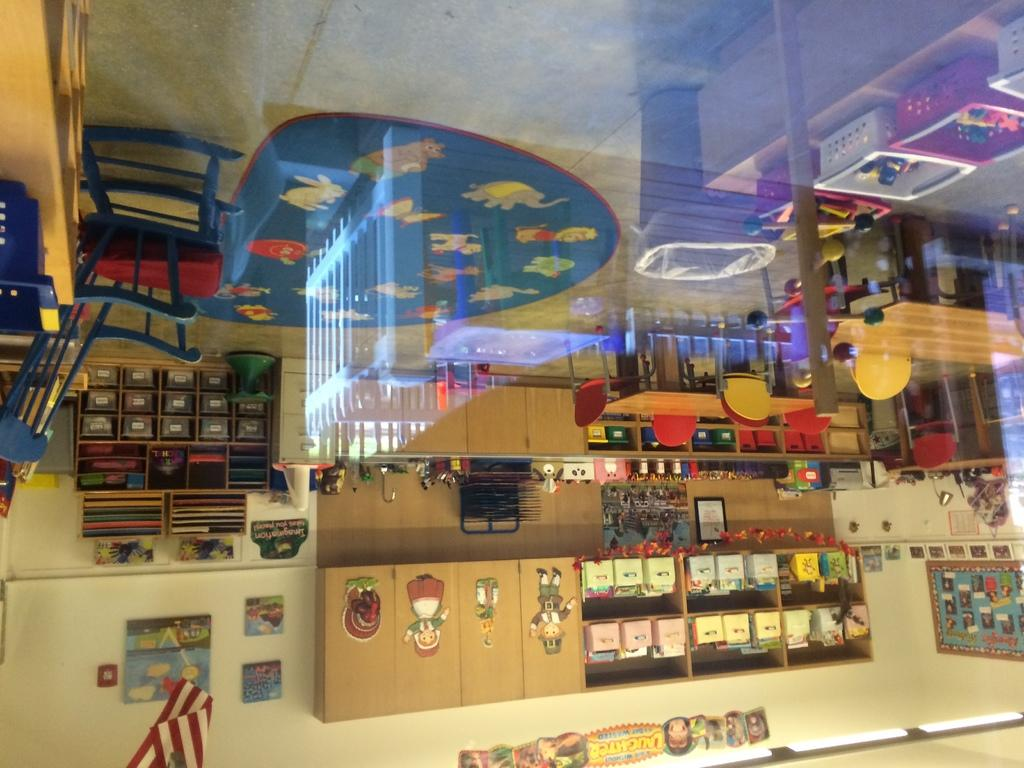What type of furniture is present in the image? There are tables and chairs in the image. What type of storage is present in the image? There are wooden shelves in the image. What can be found on the wooden shelves? There are objects on the wooden shelves. Can you hear the bells ringing in the image? There are no bells present in the image, so it is not possible to hear them ringing. 